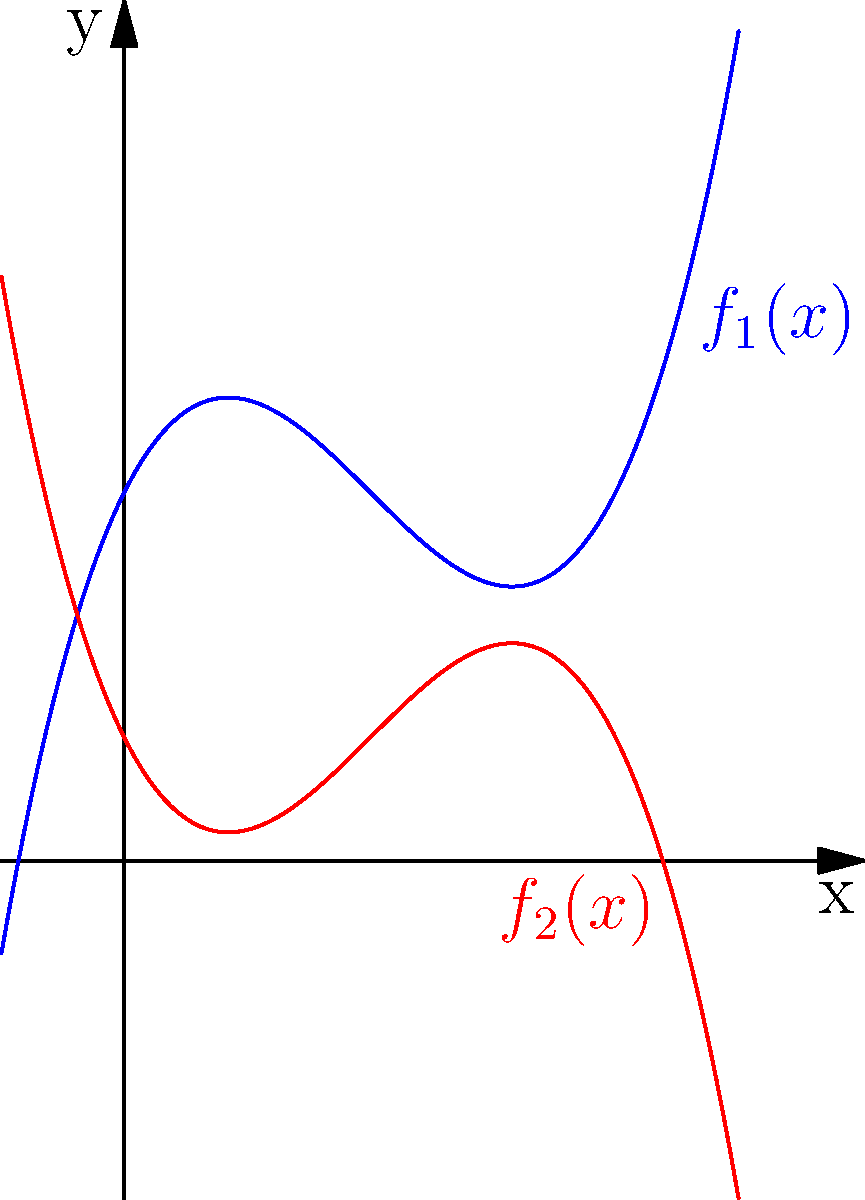You're designing a surreal landscape for your next photograph using polynomial functions. The blue curve represents a hill, and the red curve represents a valley. If $f_1(x) = 0.25x^3 - 1.5x^2 + 2x + 3$ and $f_2(x) = -0.25x^3 + 1.5x^2 - 2x + 1$, at how many points do these curves intersect within the visible range of $x \in [-1, 5]$? To find the intersection points of $f_1(x)$ and $f_2(x)$, we need to solve the equation:

$f_1(x) = f_2(x)$

$0.25x^3 - 1.5x^2 + 2x + 3 = -0.25x^3 + 1.5x^2 - 2x + 1$

Rearranging the terms:

$0.5x^3 - 3x^2 + 4x + 2 = 0$

Simplifying:

$x^3 - 6x^2 + 8x + 4 = 0$

This is a cubic equation. While it can be solved algebraically, it's complex. From the graph, we can see that the curves intersect at three points within the given range.

To verify:
1. At $x = 0$, $f_1(0) = 3$ and $f_2(0) = 1$, so they don't intersect.
2. At $x = 1$, $f_1(1) = f_2(1) = 3.75$, confirming one intersection.
3. The other two intersections occur between $x = 2$ and $x = 3$, and between $x = 3$ and $x = 4$.

Therefore, the curves intersect at 3 points within the given range.
Answer: 3 